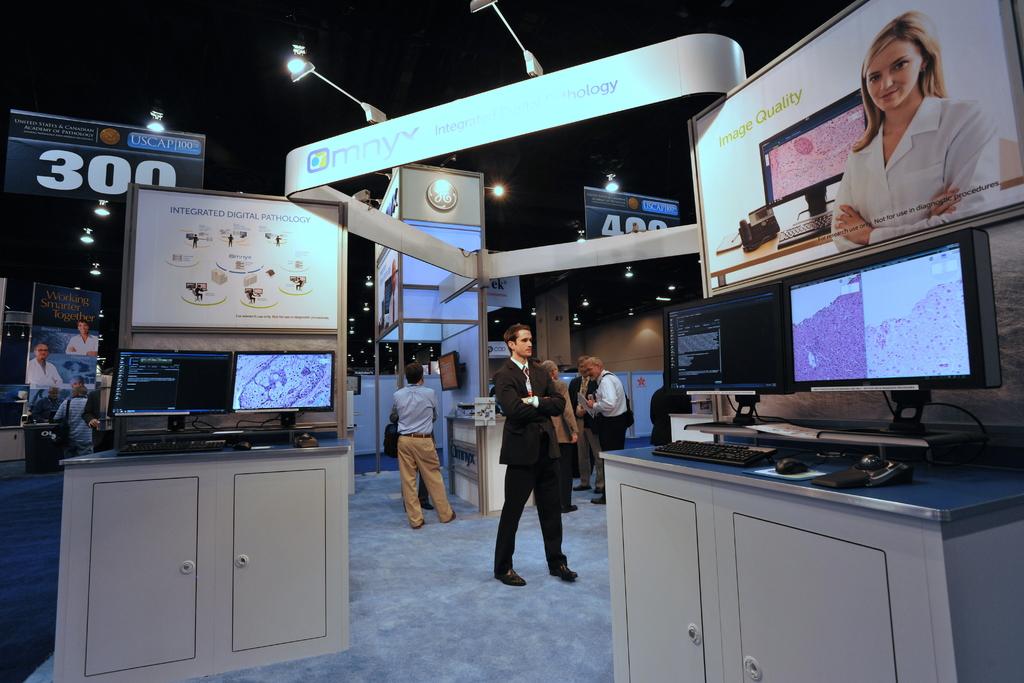What number is on the large banner?
Your response must be concise. 300. What is written on the top right display board?
Your answer should be compact. Image quality. 